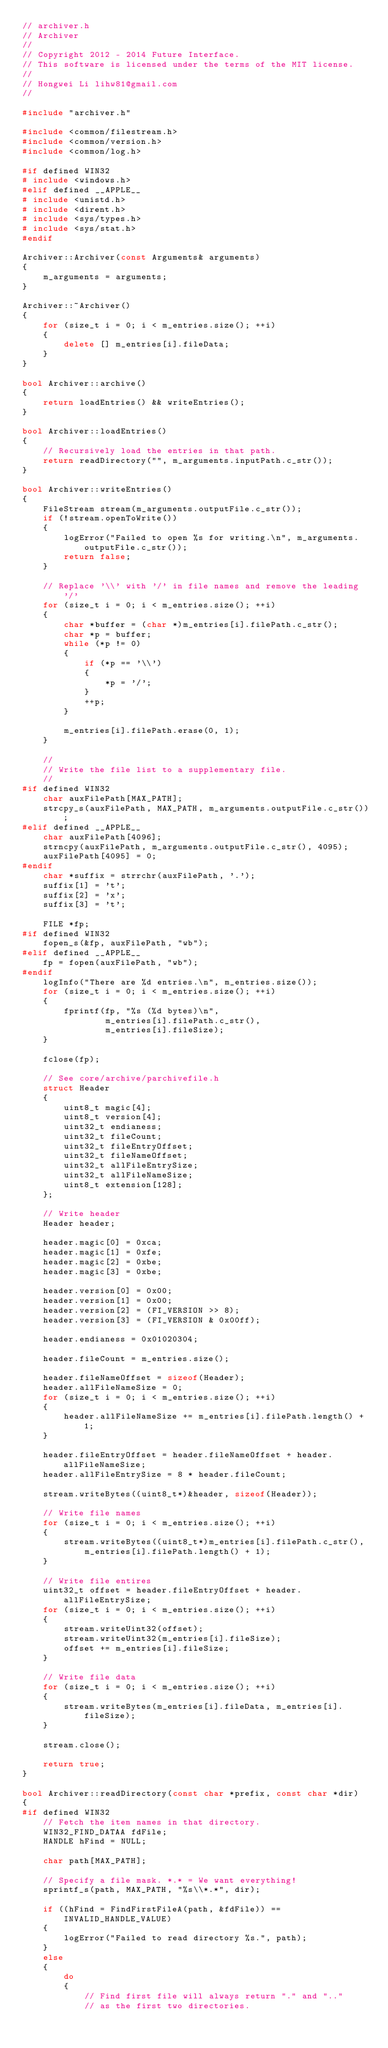<code> <loc_0><loc_0><loc_500><loc_500><_C++_>// archiver.h
// Archiver
//
// Copyright 2012 - 2014 Future Interface. 
// This software is licensed under the terms of the MIT license.
//
// Hongwei Li lihw81@gmail.com
//

#include "archiver.h"

#include <common/filestream.h>
#include <common/version.h>
#include <common/log.h>

#if defined WIN32
# include <windows.h>
#elif defined __APPLE__
# include <unistd.h>
# include <dirent.h>
# include <sys/types.h>
# include <sys/stat.h>
#endif

Archiver::Archiver(const Arguments& arguments)
{
    m_arguments = arguments;
}

Archiver::~Archiver()
{
    for (size_t i = 0; i < m_entries.size(); ++i)
    {
        delete [] m_entries[i].fileData;
    }
}

bool Archiver::archive()
{
    return loadEntries() && writeEntries();
}
    
bool Archiver::loadEntries()
{
    // Recursively load the entries in that path.
    return readDirectory("", m_arguments.inputPath.c_str());
}

bool Archiver::writeEntries()
{
    FileStream stream(m_arguments.outputFile.c_str());
    if (!stream.openToWrite())
    {
        logError("Failed to open %s for writing.\n", m_arguments.outputFile.c_str());
        return false;
    }
    
    // Replace '\\' with '/' in file names and remove the leading '/'
    for (size_t i = 0; i < m_entries.size(); ++i)
    {
        char *buffer = (char *)m_entries[i].filePath.c_str();
        char *p = buffer;
        while (*p != 0)
        {
            if (*p == '\\')
            {
                *p = '/';
            }
            ++p;
        }

        m_entries[i].filePath.erase(0, 1);
    }

    //
    // Write the file list to a supplementary file.
    //
#if defined WIN32
    char auxFilePath[MAX_PATH];
    strcpy_s(auxFilePath, MAX_PATH, m_arguments.outputFile.c_str());
#elif defined __APPLE__
    char auxFilePath[4096];
    strncpy(auxFilePath, m_arguments.outputFile.c_str(), 4095);
    auxFilePath[4095] = 0;
#endif
    char *suffix = strrchr(auxFilePath, '.');
    suffix[1] = 't';
    suffix[2] = 'x';
    suffix[3] = 't';

    FILE *fp;
#if defined WIN32
    fopen_s(&fp, auxFilePath, "wb");
#elif defined __APPLE__
    fp = fopen(auxFilePath, "wb");
#endif
    logInfo("There are %d entries.\n", m_entries.size());
    for (size_t i = 0; i < m_entries.size(); ++i)
    {
        fprintf(fp, "%s (%d bytes)\n", 
                m_entries[i].filePath.c_str(),
                m_entries[i].fileSize);
    }

    fclose(fp);

    // See core/archive/parchivefile.h
    struct Header
    {
        uint8_t magic[4];
        uint8_t version[4];
        uint32_t endianess;
        uint32_t fileCount;
        uint32_t fileEntryOffset;
        uint32_t fileNameOffset;
        uint32_t allFileEntrySize;
        uint32_t allFileNameSize;
        uint8_t extension[128];
    };

    // Write header
    Header header;

    header.magic[0] = 0xca;
    header.magic[1] = 0xfe;
    header.magic[2] = 0xbe;
    header.magic[3] = 0xbe;
    
    header.version[0] = 0x00;
    header.version[1] = 0x00;
    header.version[2] = (FI_VERSION >> 8);
    header.version[3] = (FI_VERSION & 0x00ff);

    header.endianess = 0x01020304;

    header.fileCount = m_entries.size();

    header.fileNameOffset = sizeof(Header);
    header.allFileNameSize = 0;
    for (size_t i = 0; i < m_entries.size(); ++i)
    {
        header.allFileNameSize += m_entries[i].filePath.length() + 1;
    }

    header.fileEntryOffset = header.fileNameOffset + header.allFileNameSize;
    header.allFileEntrySize = 8 * header.fileCount;

    stream.writeBytes((uint8_t*)&header, sizeof(Header));

    // Write file names
    for (size_t i = 0; i < m_entries.size(); ++i)
    {
        stream.writeBytes((uint8_t*)m_entries[i].filePath.c_str(), 
            m_entries[i].filePath.length() + 1);
    }

    // Write file entires
    uint32_t offset = header.fileEntryOffset + header.allFileEntrySize;
    for (size_t i = 0; i < m_entries.size(); ++i)
    {
        stream.writeUint32(offset);
        stream.writeUint32(m_entries[i].fileSize);
        offset += m_entries[i].fileSize;
    }

    // Write file data
    for (size_t i = 0; i < m_entries.size(); ++i)
    {
        stream.writeBytes(m_entries[i].fileData, m_entries[i].fileSize);
    }

    stream.close();

    return true;
}

bool Archiver::readDirectory(const char *prefix, const char *dir)
{
#if defined WIN32
    // Fetch the item names in that directory.
    WIN32_FIND_DATAA fdFile;
    HANDLE hFind = NULL;

    char path[MAX_PATH];

    // Specify a file mask. *.* = We want everything!
    sprintf_s(path, MAX_PATH, "%s\\*.*", dir);

    if ((hFind = FindFirstFileA(path, &fdFile)) == INVALID_HANDLE_VALUE)
    {
        logError("Failed to read directory %s.", path);
    }
    else
    {
        do
        {
            // Find first file will always return "." and ".." 
            // as the first two directories.</code> 